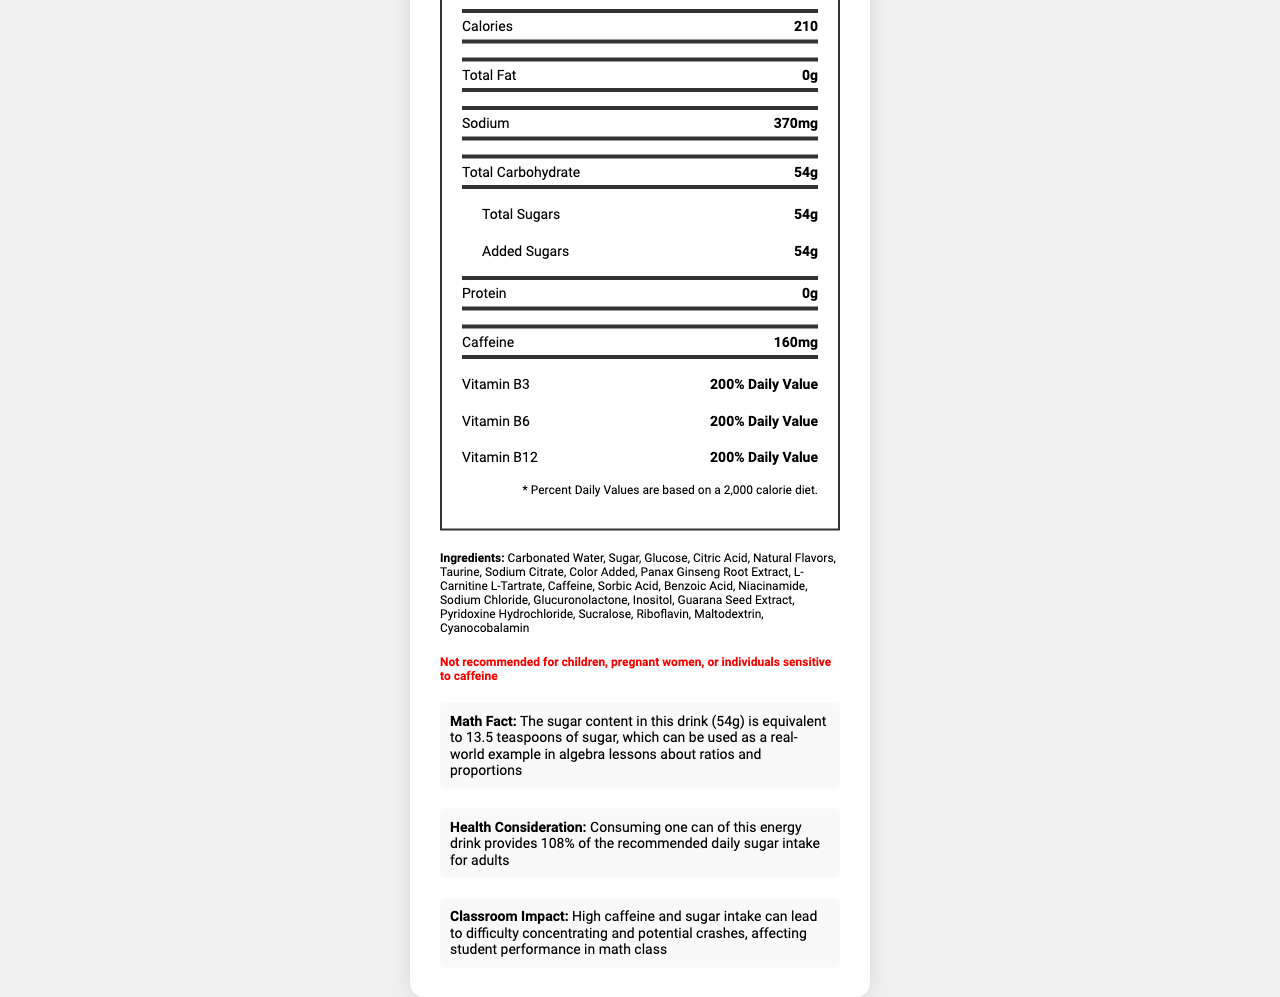what is the serving size for Monster Energy Original? The serving size is listed at the top of the Nutrition Facts section and states "16 fl oz (473 mL)".
Answer: 16 fl oz (473 mL) how much caffeine is in one serving of Monster Energy Original? The amount of caffeine is listed under the nutrients section and states "Caffeine 160mg".
Answer: 160mg how much sugar does this energy drink contain? Both the Total Sugars and Added Sugars are listed as 54g under the carbohydrates section.
Answer: 54g what is the calorie content per serving? The calorie content is prominently displayed in the main nutrients section and states "Calories 210".
Answer: 210 how much sodium is in the drink? The amount of sodium is displayed in the main nutrients section and states "Sodium 370mg".
Answer: 370mg which vitamins are listed and their daily values in the drink? A. Vitamin C, Vitamin E B. Vitamin B3, Vitamin B6, Vitamin B12 C. Vitamin A, Vitamin D The document states that Vitamin B3, Vitamin B6, and Vitamin B12 each have a 200% Daily Value.
Answer: B how many servings are in each container? A. 1 B. 2 C. 3 D. 4 The serving information details "Servings Per Container 1".
Answer: A is there any protein in this energy drink? The nutrient section clearly states "Protein 0g".
Answer: No do the ingredients include caffeine? The ingredient list includes "Caffeine".
Answer: Yes are children recommended to consume this energy drink? The warning at the bottom clearly states "Not recommended for children".
Answer: No summarize the main health considerations expressed in this document. The document highlights that one can provides 108% of the daily recommended sugar intake and warns that high caffeine may impact concentration and performance.
Answer: High sugar and caffeine content pose health risks what is the main idea of the classroom impact section? The classroom impact section mentions that high intake of sugar and caffeine can lead to difficulties in concentration and potential crashes affecting student performance in math class.
Answer: Energy drinks can affect student performance due to high caffeine and sugar what is the importance of the math fact mentioned? The math fact explains that the sugar content equates to 13.5 teaspoons, useful for algebra lessons about ratios and proportions.
Answer: It relates sugar content to real-world math examples what is the significance of the health consideration note regarding sugar intake? This helps highlight the high sugar content of the drink in relation to daily dietary guidelines.
Answer: One can provides 108% of the recommended daily sugar intake for adults what are some of the effects of high caffeine on students mentioned? The classroom impact section states that high caffeine can lead to these issues, affecting math class performance.
Answer: Difficulty concentrating and potential crashes can we determine how much fat is in the drink? The nutrient section prominently lists "Total Fat 0g".
Answer: Yes, 0 grams can we find out how much Vitamin D is in the drink? The document does not mention Vitamin D.
Answer: Not enough information 